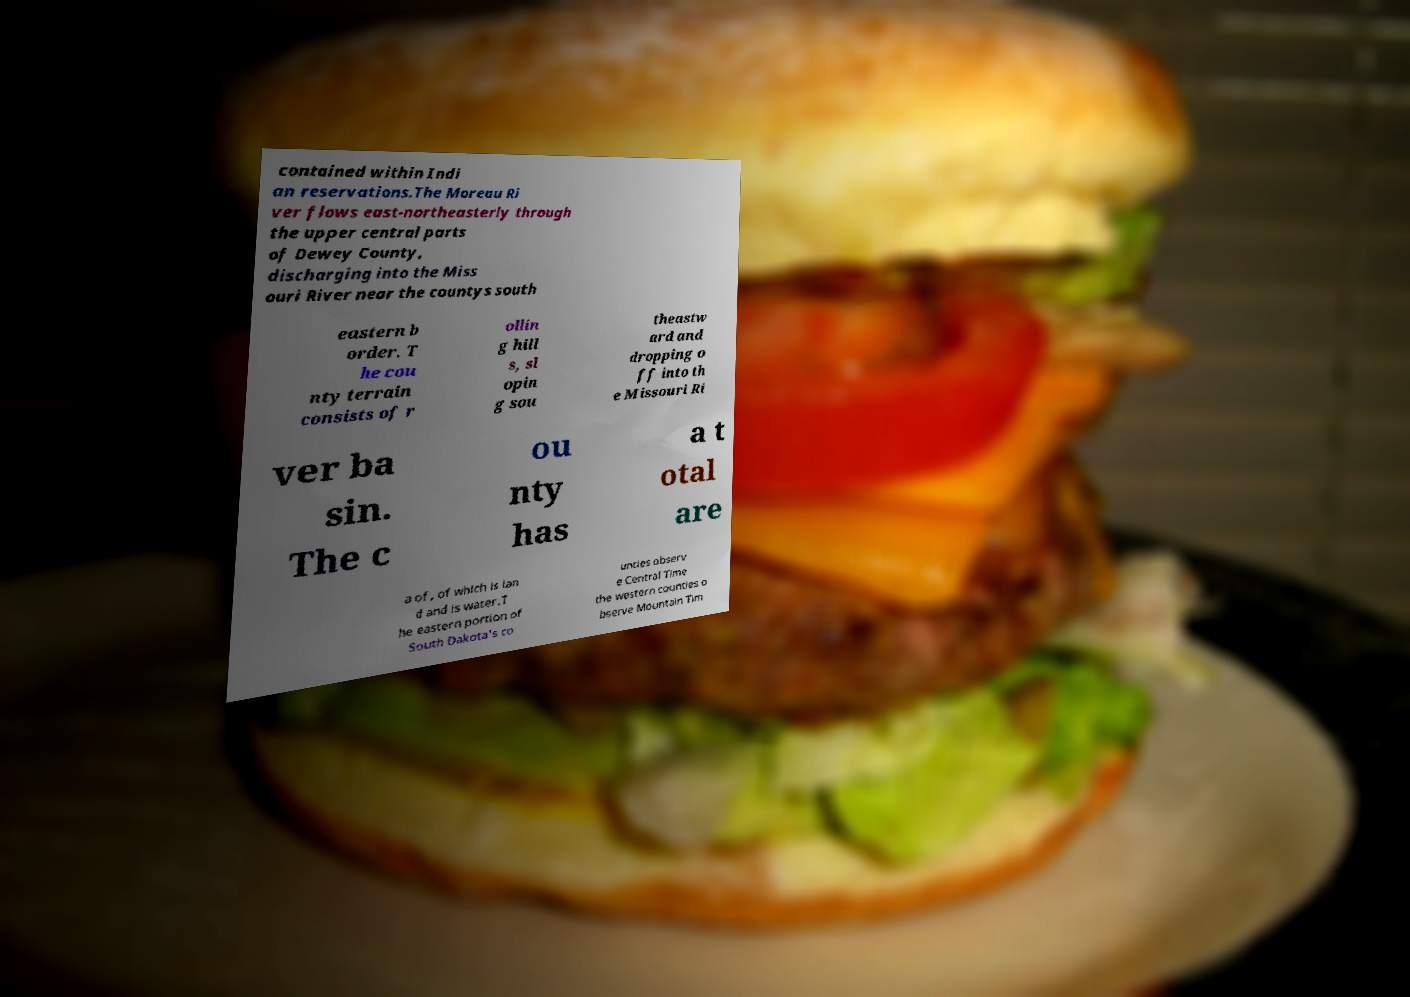There's text embedded in this image that I need extracted. Can you transcribe it verbatim? contained within Indi an reservations.The Moreau Ri ver flows east-northeasterly through the upper central parts of Dewey County, discharging into the Miss ouri River near the countys south eastern b order. T he cou nty terrain consists of r ollin g hill s, sl opin g sou theastw ard and dropping o ff into th e Missouri Ri ver ba sin. The c ou nty has a t otal are a of , of which is lan d and is water.T he eastern portion of South Dakota's co unties observ e Central Time the western counties o bserve Mountain Tim 